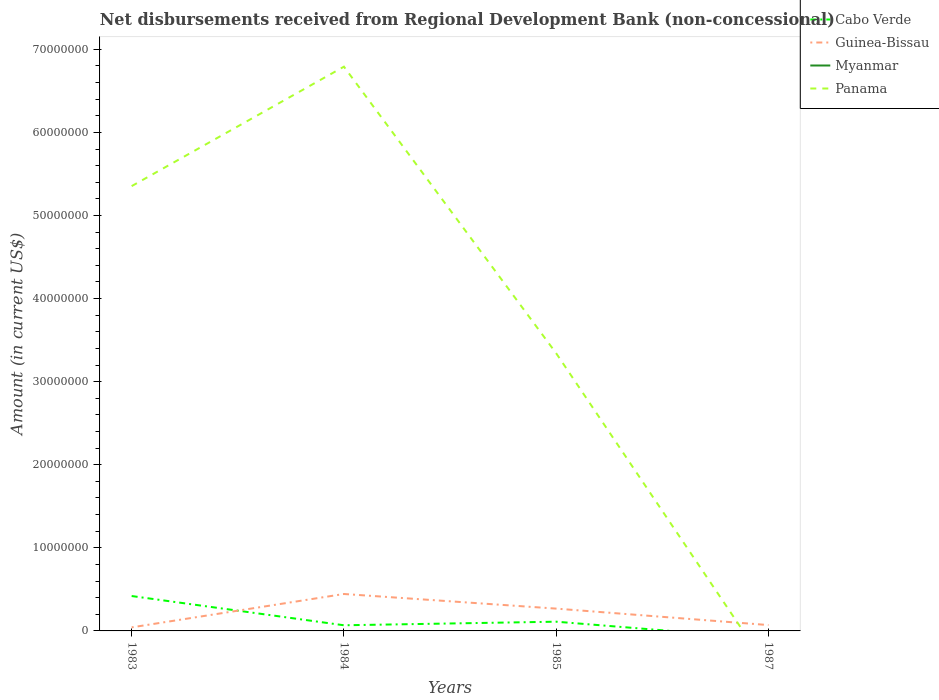How many different coloured lines are there?
Offer a very short reply. 3. Does the line corresponding to Cabo Verde intersect with the line corresponding to Myanmar?
Give a very brief answer. Yes. Across all years, what is the maximum amount of disbursements received from Regional Development Bank in Guinea-Bissau?
Your answer should be compact. 4.28e+05. What is the total amount of disbursements received from Regional Development Bank in Panama in the graph?
Ensure brevity in your answer.  2.01e+07. What is the difference between the highest and the second highest amount of disbursements received from Regional Development Bank in Guinea-Bissau?
Make the answer very short. 4.02e+06. What is the difference between the highest and the lowest amount of disbursements received from Regional Development Bank in Myanmar?
Your answer should be very brief. 0. Is the amount of disbursements received from Regional Development Bank in Panama strictly greater than the amount of disbursements received from Regional Development Bank in Guinea-Bissau over the years?
Keep it short and to the point. No. How many lines are there?
Keep it short and to the point. 3. How are the legend labels stacked?
Keep it short and to the point. Vertical. What is the title of the graph?
Ensure brevity in your answer.  Net disbursements received from Regional Development Bank (non-concessional). What is the Amount (in current US$) of Cabo Verde in 1983?
Offer a very short reply. 4.20e+06. What is the Amount (in current US$) of Guinea-Bissau in 1983?
Provide a succinct answer. 4.28e+05. What is the Amount (in current US$) in Panama in 1983?
Give a very brief answer. 5.35e+07. What is the Amount (in current US$) of Cabo Verde in 1984?
Give a very brief answer. 6.80e+05. What is the Amount (in current US$) of Guinea-Bissau in 1984?
Ensure brevity in your answer.  4.45e+06. What is the Amount (in current US$) in Myanmar in 1984?
Make the answer very short. 0. What is the Amount (in current US$) of Panama in 1984?
Keep it short and to the point. 6.79e+07. What is the Amount (in current US$) of Cabo Verde in 1985?
Your response must be concise. 1.11e+06. What is the Amount (in current US$) in Guinea-Bissau in 1985?
Provide a succinct answer. 2.68e+06. What is the Amount (in current US$) of Panama in 1985?
Ensure brevity in your answer.  3.34e+07. What is the Amount (in current US$) in Guinea-Bissau in 1987?
Make the answer very short. 7.05e+05. What is the Amount (in current US$) of Myanmar in 1987?
Your answer should be very brief. 0. Across all years, what is the maximum Amount (in current US$) of Cabo Verde?
Give a very brief answer. 4.20e+06. Across all years, what is the maximum Amount (in current US$) of Guinea-Bissau?
Offer a very short reply. 4.45e+06. Across all years, what is the maximum Amount (in current US$) in Panama?
Provide a short and direct response. 6.79e+07. Across all years, what is the minimum Amount (in current US$) of Cabo Verde?
Your answer should be compact. 0. Across all years, what is the minimum Amount (in current US$) of Guinea-Bissau?
Your answer should be very brief. 4.28e+05. What is the total Amount (in current US$) of Cabo Verde in the graph?
Offer a terse response. 5.99e+06. What is the total Amount (in current US$) of Guinea-Bissau in the graph?
Offer a terse response. 8.26e+06. What is the total Amount (in current US$) in Myanmar in the graph?
Ensure brevity in your answer.  0. What is the total Amount (in current US$) of Panama in the graph?
Give a very brief answer. 1.55e+08. What is the difference between the Amount (in current US$) in Cabo Verde in 1983 and that in 1984?
Make the answer very short. 3.52e+06. What is the difference between the Amount (in current US$) of Guinea-Bissau in 1983 and that in 1984?
Make the answer very short. -4.02e+06. What is the difference between the Amount (in current US$) of Panama in 1983 and that in 1984?
Ensure brevity in your answer.  -1.44e+07. What is the difference between the Amount (in current US$) of Cabo Verde in 1983 and that in 1985?
Your response must be concise. 3.09e+06. What is the difference between the Amount (in current US$) of Guinea-Bissau in 1983 and that in 1985?
Keep it short and to the point. -2.26e+06. What is the difference between the Amount (in current US$) of Panama in 1983 and that in 1985?
Ensure brevity in your answer.  2.01e+07. What is the difference between the Amount (in current US$) of Guinea-Bissau in 1983 and that in 1987?
Make the answer very short. -2.77e+05. What is the difference between the Amount (in current US$) in Cabo Verde in 1984 and that in 1985?
Give a very brief answer. -4.31e+05. What is the difference between the Amount (in current US$) in Guinea-Bissau in 1984 and that in 1985?
Offer a very short reply. 1.76e+06. What is the difference between the Amount (in current US$) of Panama in 1984 and that in 1985?
Your response must be concise. 3.45e+07. What is the difference between the Amount (in current US$) of Guinea-Bissau in 1984 and that in 1987?
Make the answer very short. 3.74e+06. What is the difference between the Amount (in current US$) of Guinea-Bissau in 1985 and that in 1987?
Provide a short and direct response. 1.98e+06. What is the difference between the Amount (in current US$) of Cabo Verde in 1983 and the Amount (in current US$) of Guinea-Bissau in 1984?
Make the answer very short. -2.46e+05. What is the difference between the Amount (in current US$) of Cabo Verde in 1983 and the Amount (in current US$) of Panama in 1984?
Keep it short and to the point. -6.37e+07. What is the difference between the Amount (in current US$) in Guinea-Bissau in 1983 and the Amount (in current US$) in Panama in 1984?
Your response must be concise. -6.75e+07. What is the difference between the Amount (in current US$) in Cabo Verde in 1983 and the Amount (in current US$) in Guinea-Bissau in 1985?
Your answer should be compact. 1.52e+06. What is the difference between the Amount (in current US$) in Cabo Verde in 1983 and the Amount (in current US$) in Panama in 1985?
Give a very brief answer. -2.92e+07. What is the difference between the Amount (in current US$) of Guinea-Bissau in 1983 and the Amount (in current US$) of Panama in 1985?
Offer a very short reply. -3.30e+07. What is the difference between the Amount (in current US$) of Cabo Verde in 1983 and the Amount (in current US$) of Guinea-Bissau in 1987?
Your answer should be compact. 3.50e+06. What is the difference between the Amount (in current US$) of Cabo Verde in 1984 and the Amount (in current US$) of Guinea-Bissau in 1985?
Your answer should be compact. -2.00e+06. What is the difference between the Amount (in current US$) of Cabo Verde in 1984 and the Amount (in current US$) of Panama in 1985?
Keep it short and to the point. -3.27e+07. What is the difference between the Amount (in current US$) in Guinea-Bissau in 1984 and the Amount (in current US$) in Panama in 1985?
Keep it short and to the point. -2.90e+07. What is the difference between the Amount (in current US$) in Cabo Verde in 1984 and the Amount (in current US$) in Guinea-Bissau in 1987?
Your answer should be compact. -2.50e+04. What is the difference between the Amount (in current US$) in Cabo Verde in 1985 and the Amount (in current US$) in Guinea-Bissau in 1987?
Your answer should be very brief. 4.06e+05. What is the average Amount (in current US$) in Cabo Verde per year?
Offer a very short reply. 1.50e+06. What is the average Amount (in current US$) of Guinea-Bissau per year?
Your answer should be compact. 2.07e+06. What is the average Amount (in current US$) in Panama per year?
Keep it short and to the point. 3.87e+07. In the year 1983, what is the difference between the Amount (in current US$) in Cabo Verde and Amount (in current US$) in Guinea-Bissau?
Offer a terse response. 3.77e+06. In the year 1983, what is the difference between the Amount (in current US$) of Cabo Verde and Amount (in current US$) of Panama?
Provide a short and direct response. -4.93e+07. In the year 1983, what is the difference between the Amount (in current US$) in Guinea-Bissau and Amount (in current US$) in Panama?
Keep it short and to the point. -5.31e+07. In the year 1984, what is the difference between the Amount (in current US$) in Cabo Verde and Amount (in current US$) in Guinea-Bissau?
Your answer should be very brief. -3.77e+06. In the year 1984, what is the difference between the Amount (in current US$) of Cabo Verde and Amount (in current US$) of Panama?
Your answer should be compact. -6.72e+07. In the year 1984, what is the difference between the Amount (in current US$) in Guinea-Bissau and Amount (in current US$) in Panama?
Your answer should be compact. -6.35e+07. In the year 1985, what is the difference between the Amount (in current US$) in Cabo Verde and Amount (in current US$) in Guinea-Bissau?
Offer a very short reply. -1.57e+06. In the year 1985, what is the difference between the Amount (in current US$) of Cabo Verde and Amount (in current US$) of Panama?
Your response must be concise. -3.23e+07. In the year 1985, what is the difference between the Amount (in current US$) in Guinea-Bissau and Amount (in current US$) in Panama?
Ensure brevity in your answer.  -3.07e+07. What is the ratio of the Amount (in current US$) in Cabo Verde in 1983 to that in 1984?
Provide a short and direct response. 6.18. What is the ratio of the Amount (in current US$) of Guinea-Bissau in 1983 to that in 1984?
Offer a terse response. 0.1. What is the ratio of the Amount (in current US$) of Panama in 1983 to that in 1984?
Offer a very short reply. 0.79. What is the ratio of the Amount (in current US$) in Cabo Verde in 1983 to that in 1985?
Ensure brevity in your answer.  3.78. What is the ratio of the Amount (in current US$) of Guinea-Bissau in 1983 to that in 1985?
Offer a terse response. 0.16. What is the ratio of the Amount (in current US$) in Panama in 1983 to that in 1985?
Keep it short and to the point. 1.6. What is the ratio of the Amount (in current US$) in Guinea-Bissau in 1983 to that in 1987?
Offer a terse response. 0.61. What is the ratio of the Amount (in current US$) of Cabo Verde in 1984 to that in 1985?
Provide a succinct answer. 0.61. What is the ratio of the Amount (in current US$) of Guinea-Bissau in 1984 to that in 1985?
Your answer should be very brief. 1.66. What is the ratio of the Amount (in current US$) in Panama in 1984 to that in 1985?
Keep it short and to the point. 2.03. What is the ratio of the Amount (in current US$) in Guinea-Bissau in 1984 to that in 1987?
Offer a terse response. 6.31. What is the ratio of the Amount (in current US$) of Guinea-Bissau in 1985 to that in 1987?
Keep it short and to the point. 3.81. What is the difference between the highest and the second highest Amount (in current US$) in Cabo Verde?
Keep it short and to the point. 3.09e+06. What is the difference between the highest and the second highest Amount (in current US$) of Guinea-Bissau?
Offer a very short reply. 1.76e+06. What is the difference between the highest and the second highest Amount (in current US$) of Panama?
Provide a short and direct response. 1.44e+07. What is the difference between the highest and the lowest Amount (in current US$) in Cabo Verde?
Offer a very short reply. 4.20e+06. What is the difference between the highest and the lowest Amount (in current US$) of Guinea-Bissau?
Keep it short and to the point. 4.02e+06. What is the difference between the highest and the lowest Amount (in current US$) of Panama?
Offer a terse response. 6.79e+07. 